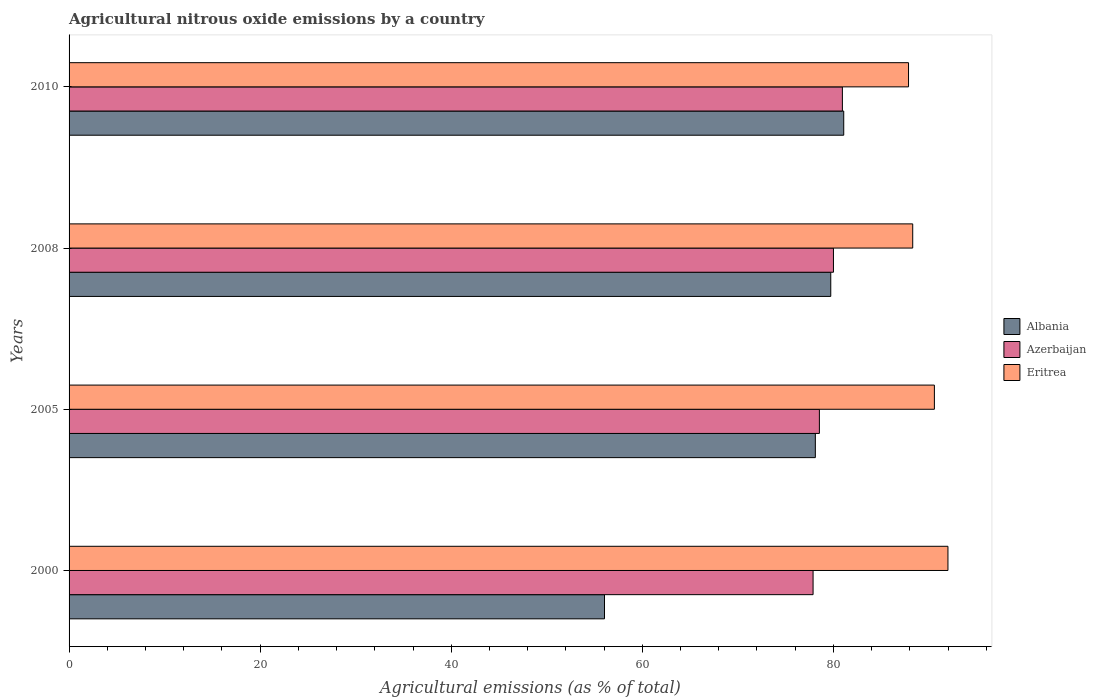How many bars are there on the 4th tick from the bottom?
Provide a short and direct response. 3. What is the label of the 2nd group of bars from the top?
Your answer should be compact. 2008. What is the amount of agricultural nitrous oxide emitted in Eritrea in 2005?
Give a very brief answer. 90.57. Across all years, what is the maximum amount of agricultural nitrous oxide emitted in Eritrea?
Offer a very short reply. 91.99. Across all years, what is the minimum amount of agricultural nitrous oxide emitted in Albania?
Give a very brief answer. 56.04. What is the total amount of agricultural nitrous oxide emitted in Albania in the graph?
Offer a terse response. 294.95. What is the difference between the amount of agricultural nitrous oxide emitted in Azerbaijan in 2005 and that in 2008?
Your answer should be compact. -1.47. What is the difference between the amount of agricultural nitrous oxide emitted in Eritrea in 2000 and the amount of agricultural nitrous oxide emitted in Azerbaijan in 2008?
Keep it short and to the point. 11.98. What is the average amount of agricultural nitrous oxide emitted in Azerbaijan per year?
Ensure brevity in your answer.  79.34. In the year 2008, what is the difference between the amount of agricultural nitrous oxide emitted in Eritrea and amount of agricultural nitrous oxide emitted in Azerbaijan?
Your answer should be very brief. 8.3. In how many years, is the amount of agricultural nitrous oxide emitted in Azerbaijan greater than 52 %?
Your response must be concise. 4. What is the ratio of the amount of agricultural nitrous oxide emitted in Eritrea in 2005 to that in 2008?
Provide a short and direct response. 1.03. Is the amount of agricultural nitrous oxide emitted in Albania in 2000 less than that in 2010?
Your response must be concise. Yes. Is the difference between the amount of agricultural nitrous oxide emitted in Eritrea in 2005 and 2010 greater than the difference between the amount of agricultural nitrous oxide emitted in Azerbaijan in 2005 and 2010?
Your answer should be very brief. Yes. What is the difference between the highest and the second highest amount of agricultural nitrous oxide emitted in Albania?
Keep it short and to the point. 1.36. What is the difference between the highest and the lowest amount of agricultural nitrous oxide emitted in Albania?
Your answer should be very brief. 25.04. In how many years, is the amount of agricultural nitrous oxide emitted in Eritrea greater than the average amount of agricultural nitrous oxide emitted in Eritrea taken over all years?
Offer a terse response. 2. Is the sum of the amount of agricultural nitrous oxide emitted in Eritrea in 2000 and 2005 greater than the maximum amount of agricultural nitrous oxide emitted in Albania across all years?
Your answer should be compact. Yes. What does the 2nd bar from the top in 2010 represents?
Your answer should be compact. Azerbaijan. What does the 1st bar from the bottom in 2008 represents?
Make the answer very short. Albania. Is it the case that in every year, the sum of the amount of agricultural nitrous oxide emitted in Albania and amount of agricultural nitrous oxide emitted in Azerbaijan is greater than the amount of agricultural nitrous oxide emitted in Eritrea?
Your answer should be very brief. Yes. Are all the bars in the graph horizontal?
Give a very brief answer. Yes. Are the values on the major ticks of X-axis written in scientific E-notation?
Your response must be concise. No. Does the graph contain grids?
Your answer should be very brief. No. Where does the legend appear in the graph?
Provide a short and direct response. Center right. How many legend labels are there?
Your answer should be compact. 3. What is the title of the graph?
Your response must be concise. Agricultural nitrous oxide emissions by a country. What is the label or title of the X-axis?
Offer a very short reply. Agricultural emissions (as % of total). What is the label or title of the Y-axis?
Offer a terse response. Years. What is the Agricultural emissions (as % of total) in Albania in 2000?
Make the answer very short. 56.04. What is the Agricultural emissions (as % of total) in Azerbaijan in 2000?
Give a very brief answer. 77.87. What is the Agricultural emissions (as % of total) of Eritrea in 2000?
Your answer should be compact. 91.99. What is the Agricultural emissions (as % of total) in Albania in 2005?
Provide a succinct answer. 78.11. What is the Agricultural emissions (as % of total) of Azerbaijan in 2005?
Your response must be concise. 78.53. What is the Agricultural emissions (as % of total) of Eritrea in 2005?
Provide a succinct answer. 90.57. What is the Agricultural emissions (as % of total) in Albania in 2008?
Provide a succinct answer. 79.72. What is the Agricultural emissions (as % of total) of Azerbaijan in 2008?
Keep it short and to the point. 80. What is the Agricultural emissions (as % of total) in Eritrea in 2008?
Offer a very short reply. 88.3. What is the Agricultural emissions (as % of total) in Albania in 2010?
Make the answer very short. 81.08. What is the Agricultural emissions (as % of total) of Azerbaijan in 2010?
Offer a very short reply. 80.94. What is the Agricultural emissions (as % of total) of Eritrea in 2010?
Keep it short and to the point. 87.86. Across all years, what is the maximum Agricultural emissions (as % of total) in Albania?
Provide a short and direct response. 81.08. Across all years, what is the maximum Agricultural emissions (as % of total) in Azerbaijan?
Your answer should be compact. 80.94. Across all years, what is the maximum Agricultural emissions (as % of total) of Eritrea?
Offer a terse response. 91.99. Across all years, what is the minimum Agricultural emissions (as % of total) in Albania?
Provide a short and direct response. 56.04. Across all years, what is the minimum Agricultural emissions (as % of total) of Azerbaijan?
Offer a terse response. 77.87. Across all years, what is the minimum Agricultural emissions (as % of total) in Eritrea?
Offer a terse response. 87.86. What is the total Agricultural emissions (as % of total) in Albania in the graph?
Make the answer very short. 294.95. What is the total Agricultural emissions (as % of total) in Azerbaijan in the graph?
Your response must be concise. 317.34. What is the total Agricultural emissions (as % of total) in Eritrea in the graph?
Offer a terse response. 358.72. What is the difference between the Agricultural emissions (as % of total) of Albania in 2000 and that in 2005?
Make the answer very short. -22.07. What is the difference between the Agricultural emissions (as % of total) of Azerbaijan in 2000 and that in 2005?
Your response must be concise. -0.66. What is the difference between the Agricultural emissions (as % of total) of Eritrea in 2000 and that in 2005?
Make the answer very short. 1.42. What is the difference between the Agricultural emissions (as % of total) in Albania in 2000 and that in 2008?
Offer a very short reply. -23.68. What is the difference between the Agricultural emissions (as % of total) of Azerbaijan in 2000 and that in 2008?
Your answer should be very brief. -2.13. What is the difference between the Agricultural emissions (as % of total) in Eritrea in 2000 and that in 2008?
Your response must be concise. 3.69. What is the difference between the Agricultural emissions (as % of total) of Albania in 2000 and that in 2010?
Provide a short and direct response. -25.04. What is the difference between the Agricultural emissions (as % of total) of Azerbaijan in 2000 and that in 2010?
Your answer should be very brief. -3.07. What is the difference between the Agricultural emissions (as % of total) in Eritrea in 2000 and that in 2010?
Ensure brevity in your answer.  4.13. What is the difference between the Agricultural emissions (as % of total) of Albania in 2005 and that in 2008?
Provide a succinct answer. -1.61. What is the difference between the Agricultural emissions (as % of total) of Azerbaijan in 2005 and that in 2008?
Give a very brief answer. -1.47. What is the difference between the Agricultural emissions (as % of total) in Eritrea in 2005 and that in 2008?
Your answer should be compact. 2.27. What is the difference between the Agricultural emissions (as % of total) of Albania in 2005 and that in 2010?
Your answer should be very brief. -2.97. What is the difference between the Agricultural emissions (as % of total) of Azerbaijan in 2005 and that in 2010?
Your response must be concise. -2.41. What is the difference between the Agricultural emissions (as % of total) of Eritrea in 2005 and that in 2010?
Your answer should be very brief. 2.71. What is the difference between the Agricultural emissions (as % of total) in Albania in 2008 and that in 2010?
Make the answer very short. -1.36. What is the difference between the Agricultural emissions (as % of total) in Azerbaijan in 2008 and that in 2010?
Give a very brief answer. -0.93. What is the difference between the Agricultural emissions (as % of total) in Eritrea in 2008 and that in 2010?
Keep it short and to the point. 0.44. What is the difference between the Agricultural emissions (as % of total) of Albania in 2000 and the Agricultural emissions (as % of total) of Azerbaijan in 2005?
Your answer should be very brief. -22.49. What is the difference between the Agricultural emissions (as % of total) in Albania in 2000 and the Agricultural emissions (as % of total) in Eritrea in 2005?
Your answer should be compact. -34.53. What is the difference between the Agricultural emissions (as % of total) of Azerbaijan in 2000 and the Agricultural emissions (as % of total) of Eritrea in 2005?
Ensure brevity in your answer.  -12.7. What is the difference between the Agricultural emissions (as % of total) of Albania in 2000 and the Agricultural emissions (as % of total) of Azerbaijan in 2008?
Make the answer very short. -23.96. What is the difference between the Agricultural emissions (as % of total) of Albania in 2000 and the Agricultural emissions (as % of total) of Eritrea in 2008?
Provide a succinct answer. -32.26. What is the difference between the Agricultural emissions (as % of total) in Azerbaijan in 2000 and the Agricultural emissions (as % of total) in Eritrea in 2008?
Offer a very short reply. -10.43. What is the difference between the Agricultural emissions (as % of total) in Albania in 2000 and the Agricultural emissions (as % of total) in Azerbaijan in 2010?
Keep it short and to the point. -24.9. What is the difference between the Agricultural emissions (as % of total) in Albania in 2000 and the Agricultural emissions (as % of total) in Eritrea in 2010?
Your answer should be compact. -31.82. What is the difference between the Agricultural emissions (as % of total) in Azerbaijan in 2000 and the Agricultural emissions (as % of total) in Eritrea in 2010?
Make the answer very short. -9.99. What is the difference between the Agricultural emissions (as % of total) in Albania in 2005 and the Agricultural emissions (as % of total) in Azerbaijan in 2008?
Ensure brevity in your answer.  -1.9. What is the difference between the Agricultural emissions (as % of total) in Albania in 2005 and the Agricultural emissions (as % of total) in Eritrea in 2008?
Your answer should be compact. -10.19. What is the difference between the Agricultural emissions (as % of total) in Azerbaijan in 2005 and the Agricultural emissions (as % of total) in Eritrea in 2008?
Provide a short and direct response. -9.77. What is the difference between the Agricultural emissions (as % of total) of Albania in 2005 and the Agricultural emissions (as % of total) of Azerbaijan in 2010?
Your response must be concise. -2.83. What is the difference between the Agricultural emissions (as % of total) of Albania in 2005 and the Agricultural emissions (as % of total) of Eritrea in 2010?
Offer a very short reply. -9.75. What is the difference between the Agricultural emissions (as % of total) of Azerbaijan in 2005 and the Agricultural emissions (as % of total) of Eritrea in 2010?
Offer a terse response. -9.33. What is the difference between the Agricultural emissions (as % of total) in Albania in 2008 and the Agricultural emissions (as % of total) in Azerbaijan in 2010?
Your answer should be compact. -1.22. What is the difference between the Agricultural emissions (as % of total) in Albania in 2008 and the Agricultural emissions (as % of total) in Eritrea in 2010?
Make the answer very short. -8.14. What is the difference between the Agricultural emissions (as % of total) in Azerbaijan in 2008 and the Agricultural emissions (as % of total) in Eritrea in 2010?
Ensure brevity in your answer.  -7.86. What is the average Agricultural emissions (as % of total) in Albania per year?
Give a very brief answer. 73.74. What is the average Agricultural emissions (as % of total) in Azerbaijan per year?
Offer a terse response. 79.34. What is the average Agricultural emissions (as % of total) in Eritrea per year?
Offer a terse response. 89.68. In the year 2000, what is the difference between the Agricultural emissions (as % of total) in Albania and Agricultural emissions (as % of total) in Azerbaijan?
Keep it short and to the point. -21.83. In the year 2000, what is the difference between the Agricultural emissions (as % of total) of Albania and Agricultural emissions (as % of total) of Eritrea?
Your answer should be very brief. -35.95. In the year 2000, what is the difference between the Agricultural emissions (as % of total) in Azerbaijan and Agricultural emissions (as % of total) in Eritrea?
Your answer should be compact. -14.12. In the year 2005, what is the difference between the Agricultural emissions (as % of total) of Albania and Agricultural emissions (as % of total) of Azerbaijan?
Provide a short and direct response. -0.42. In the year 2005, what is the difference between the Agricultural emissions (as % of total) in Albania and Agricultural emissions (as % of total) in Eritrea?
Offer a terse response. -12.46. In the year 2005, what is the difference between the Agricultural emissions (as % of total) of Azerbaijan and Agricultural emissions (as % of total) of Eritrea?
Keep it short and to the point. -12.04. In the year 2008, what is the difference between the Agricultural emissions (as % of total) in Albania and Agricultural emissions (as % of total) in Azerbaijan?
Your response must be concise. -0.28. In the year 2008, what is the difference between the Agricultural emissions (as % of total) of Albania and Agricultural emissions (as % of total) of Eritrea?
Give a very brief answer. -8.58. In the year 2008, what is the difference between the Agricultural emissions (as % of total) in Azerbaijan and Agricultural emissions (as % of total) in Eritrea?
Your answer should be compact. -8.3. In the year 2010, what is the difference between the Agricultural emissions (as % of total) of Albania and Agricultural emissions (as % of total) of Azerbaijan?
Ensure brevity in your answer.  0.14. In the year 2010, what is the difference between the Agricultural emissions (as % of total) of Albania and Agricultural emissions (as % of total) of Eritrea?
Offer a terse response. -6.78. In the year 2010, what is the difference between the Agricultural emissions (as % of total) in Azerbaijan and Agricultural emissions (as % of total) in Eritrea?
Keep it short and to the point. -6.92. What is the ratio of the Agricultural emissions (as % of total) of Albania in 2000 to that in 2005?
Your answer should be compact. 0.72. What is the ratio of the Agricultural emissions (as % of total) in Eritrea in 2000 to that in 2005?
Offer a very short reply. 1.02. What is the ratio of the Agricultural emissions (as % of total) in Albania in 2000 to that in 2008?
Make the answer very short. 0.7. What is the ratio of the Agricultural emissions (as % of total) in Azerbaijan in 2000 to that in 2008?
Your answer should be very brief. 0.97. What is the ratio of the Agricultural emissions (as % of total) of Eritrea in 2000 to that in 2008?
Offer a terse response. 1.04. What is the ratio of the Agricultural emissions (as % of total) of Albania in 2000 to that in 2010?
Offer a very short reply. 0.69. What is the ratio of the Agricultural emissions (as % of total) of Azerbaijan in 2000 to that in 2010?
Give a very brief answer. 0.96. What is the ratio of the Agricultural emissions (as % of total) in Eritrea in 2000 to that in 2010?
Your answer should be very brief. 1.05. What is the ratio of the Agricultural emissions (as % of total) of Albania in 2005 to that in 2008?
Provide a succinct answer. 0.98. What is the ratio of the Agricultural emissions (as % of total) in Azerbaijan in 2005 to that in 2008?
Make the answer very short. 0.98. What is the ratio of the Agricultural emissions (as % of total) of Eritrea in 2005 to that in 2008?
Your response must be concise. 1.03. What is the ratio of the Agricultural emissions (as % of total) of Albania in 2005 to that in 2010?
Offer a terse response. 0.96. What is the ratio of the Agricultural emissions (as % of total) of Azerbaijan in 2005 to that in 2010?
Your response must be concise. 0.97. What is the ratio of the Agricultural emissions (as % of total) in Eritrea in 2005 to that in 2010?
Give a very brief answer. 1.03. What is the ratio of the Agricultural emissions (as % of total) in Albania in 2008 to that in 2010?
Provide a short and direct response. 0.98. What is the ratio of the Agricultural emissions (as % of total) in Azerbaijan in 2008 to that in 2010?
Keep it short and to the point. 0.99. What is the difference between the highest and the second highest Agricultural emissions (as % of total) in Albania?
Your answer should be compact. 1.36. What is the difference between the highest and the second highest Agricultural emissions (as % of total) in Azerbaijan?
Your response must be concise. 0.93. What is the difference between the highest and the second highest Agricultural emissions (as % of total) of Eritrea?
Make the answer very short. 1.42. What is the difference between the highest and the lowest Agricultural emissions (as % of total) in Albania?
Give a very brief answer. 25.04. What is the difference between the highest and the lowest Agricultural emissions (as % of total) in Azerbaijan?
Offer a terse response. 3.07. What is the difference between the highest and the lowest Agricultural emissions (as % of total) of Eritrea?
Keep it short and to the point. 4.13. 